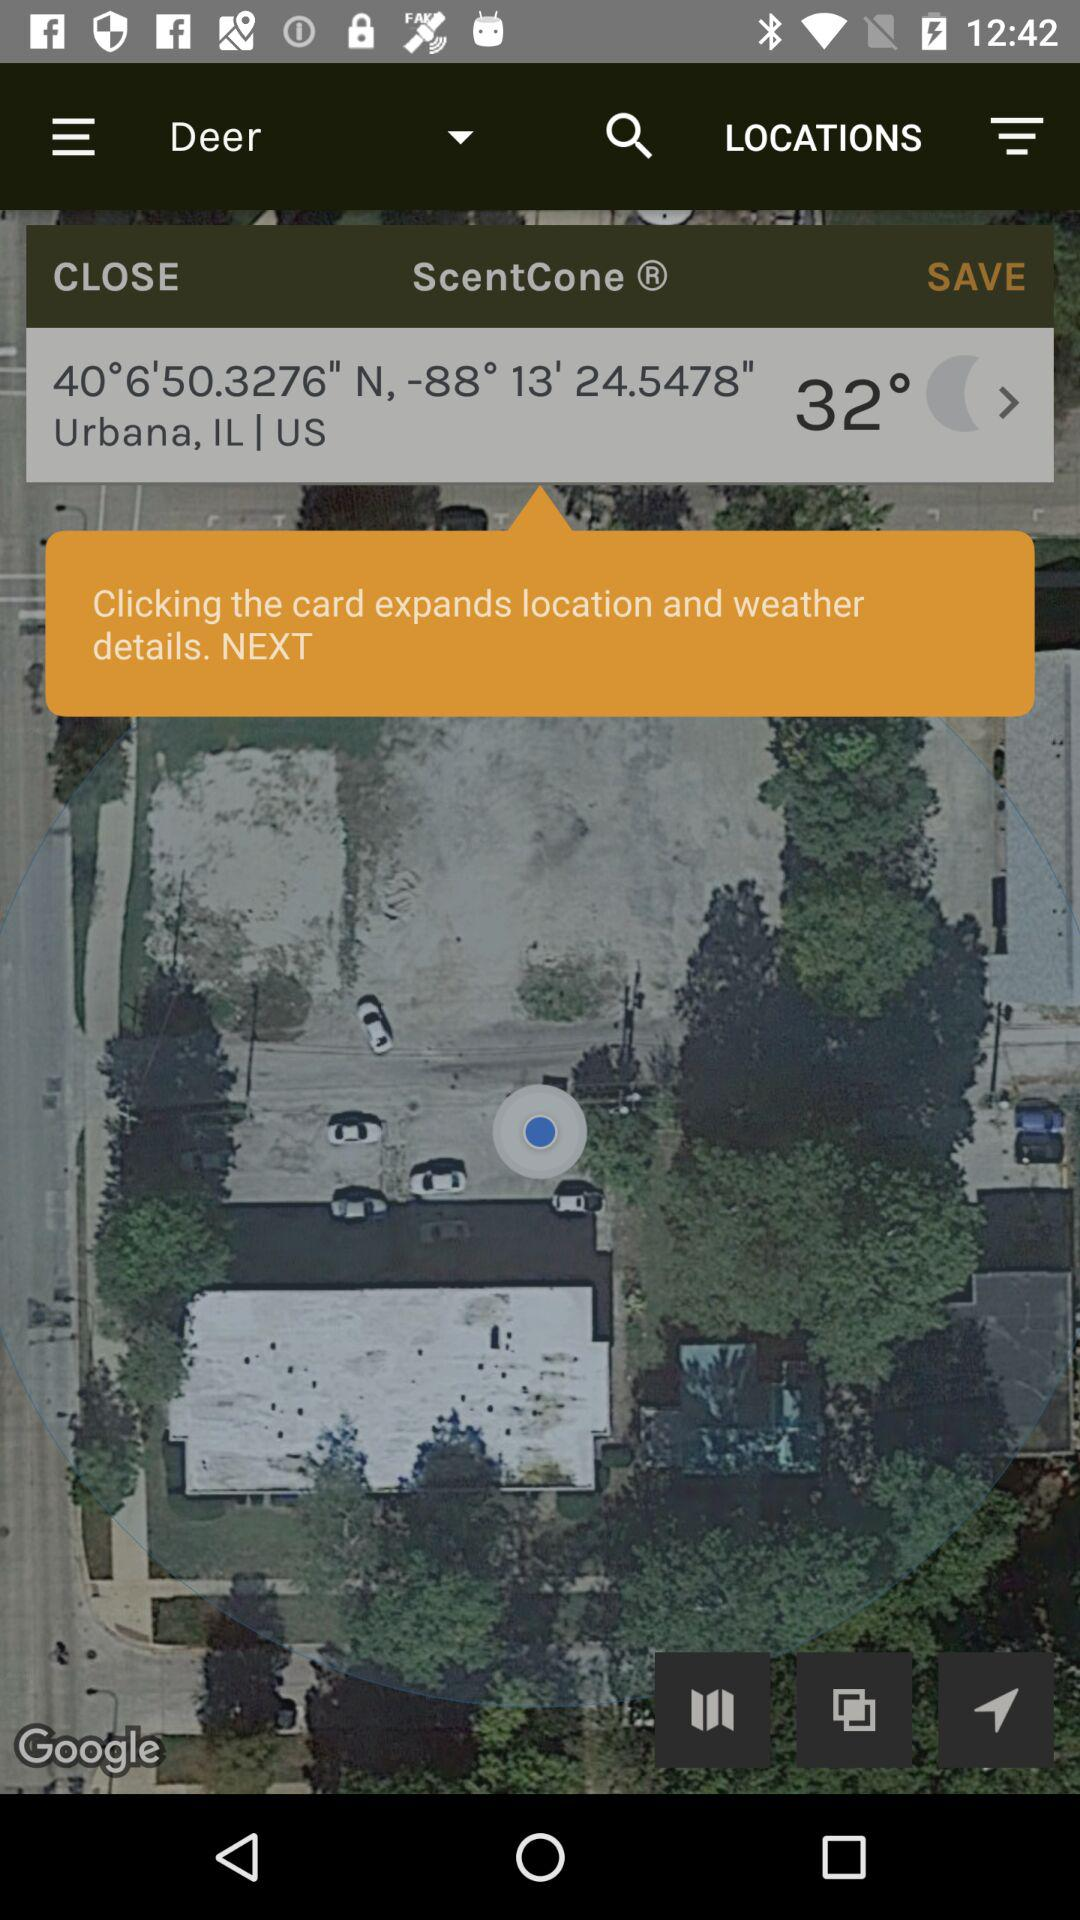What is the location? The location is Urbana, IL, US. 